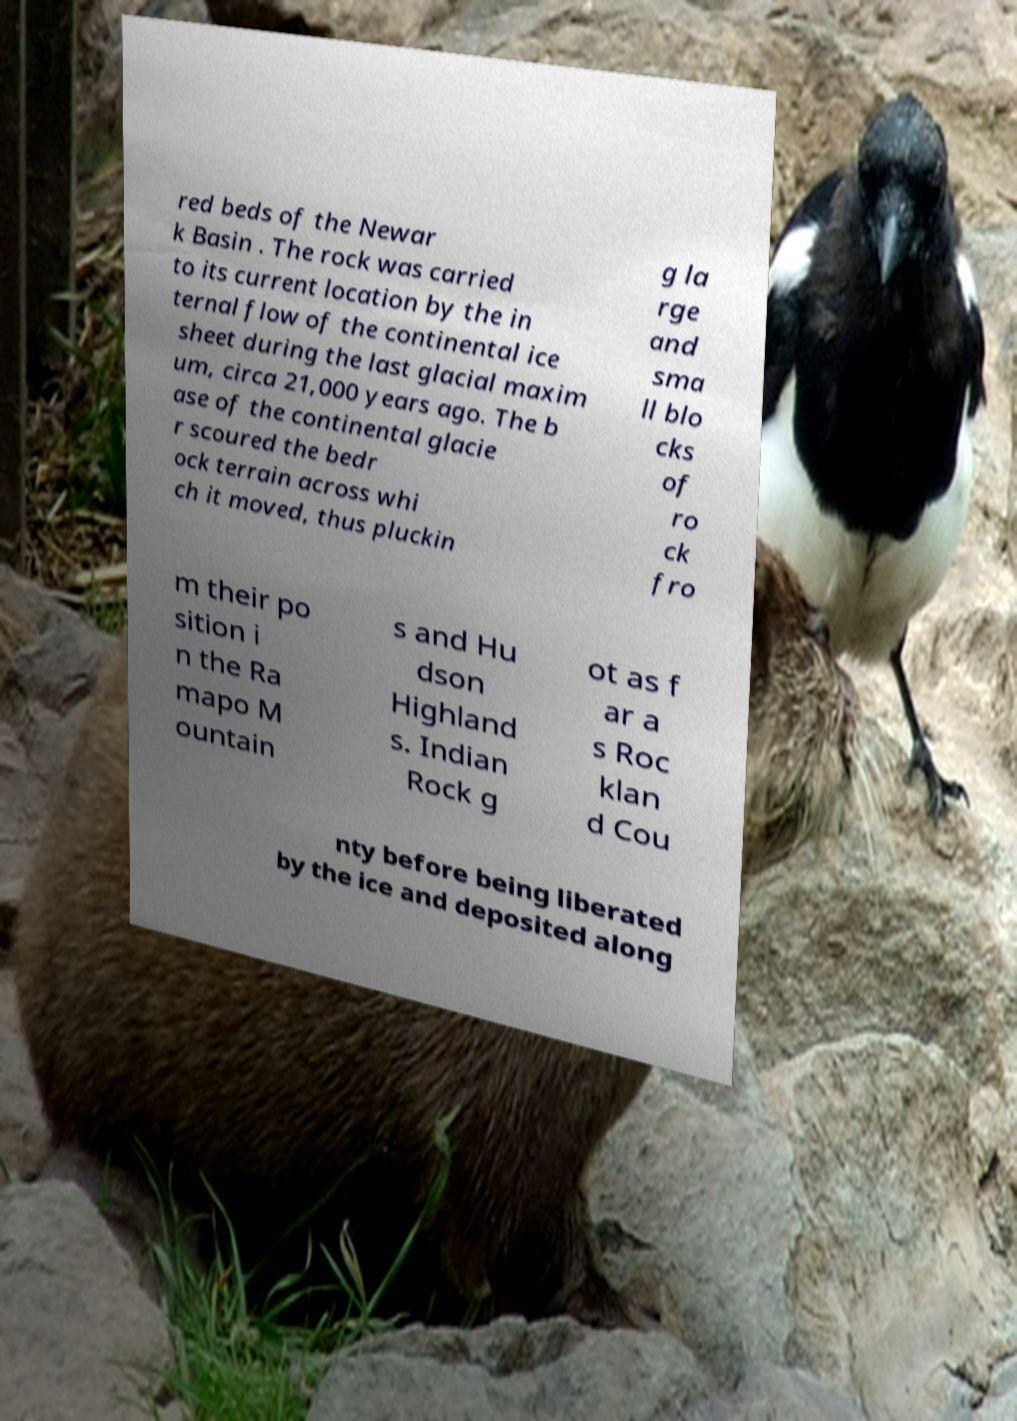For documentation purposes, I need the text within this image transcribed. Could you provide that? red beds of the Newar k Basin . The rock was carried to its current location by the in ternal flow of the continental ice sheet during the last glacial maxim um, circa 21,000 years ago. The b ase of the continental glacie r scoured the bedr ock terrain across whi ch it moved, thus pluckin g la rge and sma ll blo cks of ro ck fro m their po sition i n the Ra mapo M ountain s and Hu dson Highland s. Indian Rock g ot as f ar a s Roc klan d Cou nty before being liberated by the ice and deposited along 